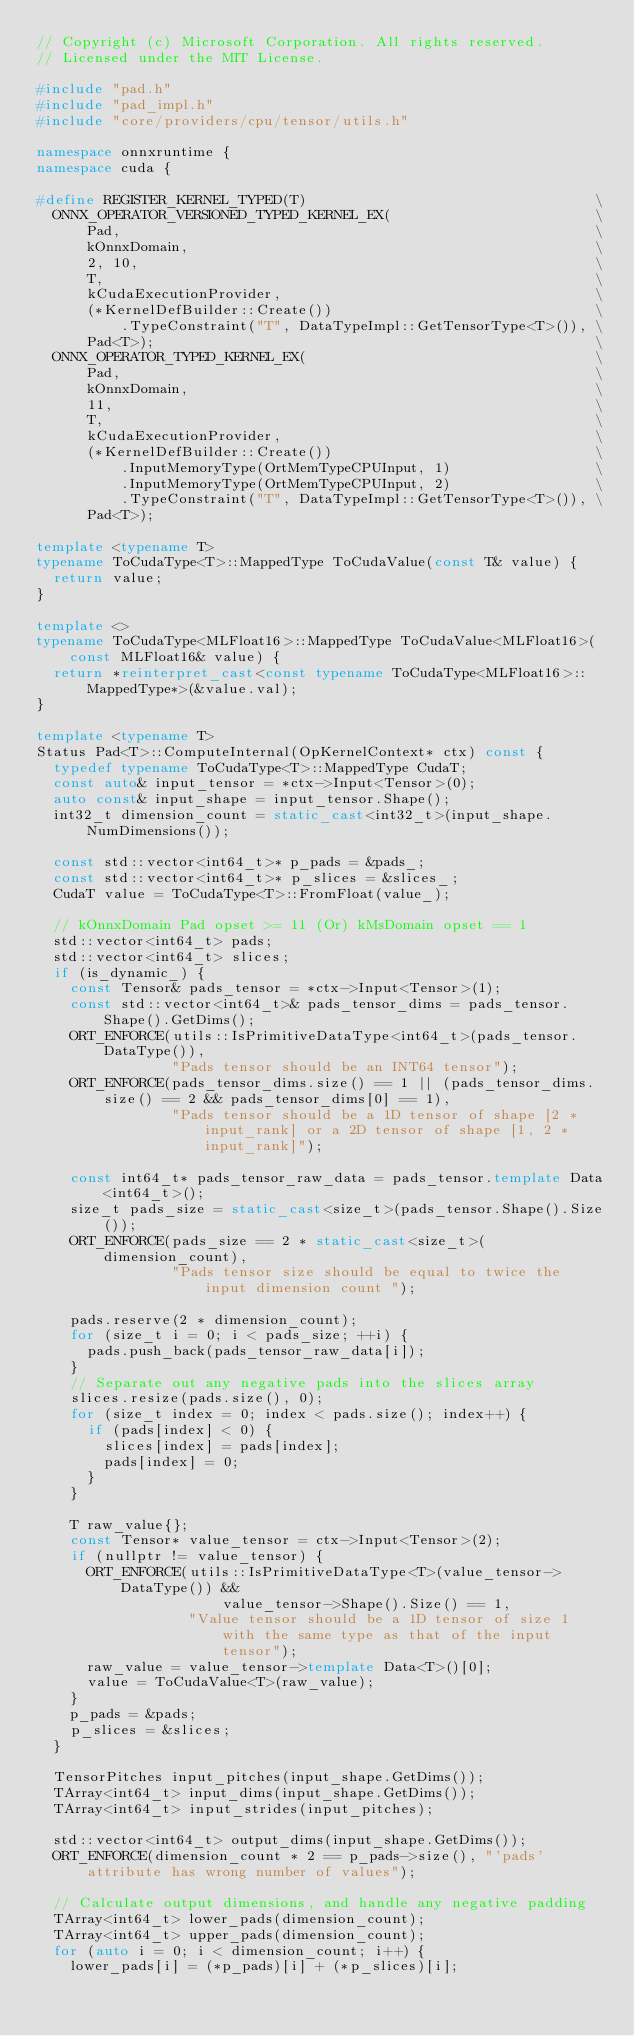Convert code to text. <code><loc_0><loc_0><loc_500><loc_500><_C++_>// Copyright (c) Microsoft Corporation. All rights reserved.
// Licensed under the MIT License.

#include "pad.h"
#include "pad_impl.h"
#include "core/providers/cpu/tensor/utils.h"

namespace onnxruntime {
namespace cuda {

#define REGISTER_KERNEL_TYPED(T)                                  \
  ONNX_OPERATOR_VERSIONED_TYPED_KERNEL_EX(                        \
      Pad,                                                        \
      kOnnxDomain,                                                \
      2, 10,                                                      \
      T,                                                          \
      kCudaExecutionProvider,                                     \
      (*KernelDefBuilder::Create())                               \
          .TypeConstraint("T", DataTypeImpl::GetTensorType<T>()), \
      Pad<T>);                                                    \
  ONNX_OPERATOR_TYPED_KERNEL_EX(                                  \
      Pad,                                                        \
      kOnnxDomain,                                                \
      11,                                                         \
      T,                                                          \
      kCudaExecutionProvider,                                     \
      (*KernelDefBuilder::Create())                               \
          .InputMemoryType(OrtMemTypeCPUInput, 1)                 \
          .InputMemoryType(OrtMemTypeCPUInput, 2)                 \
          .TypeConstraint("T", DataTypeImpl::GetTensorType<T>()), \
      Pad<T>);

template <typename T>
typename ToCudaType<T>::MappedType ToCudaValue(const T& value) {
  return value;
}

template <>
typename ToCudaType<MLFloat16>::MappedType ToCudaValue<MLFloat16>(const MLFloat16& value) {
  return *reinterpret_cast<const typename ToCudaType<MLFloat16>::MappedType*>(&value.val);
}

template <typename T>
Status Pad<T>::ComputeInternal(OpKernelContext* ctx) const {
  typedef typename ToCudaType<T>::MappedType CudaT;
  const auto& input_tensor = *ctx->Input<Tensor>(0);
  auto const& input_shape = input_tensor.Shape();
  int32_t dimension_count = static_cast<int32_t>(input_shape.NumDimensions());

  const std::vector<int64_t>* p_pads = &pads_;
  const std::vector<int64_t>* p_slices = &slices_;
  CudaT value = ToCudaType<T>::FromFloat(value_);

  // kOnnxDomain Pad opset >= 11 (Or) kMsDomain opset == 1
  std::vector<int64_t> pads;
  std::vector<int64_t> slices;
  if (is_dynamic_) {
    const Tensor& pads_tensor = *ctx->Input<Tensor>(1);
    const std::vector<int64_t>& pads_tensor_dims = pads_tensor.Shape().GetDims();
    ORT_ENFORCE(utils::IsPrimitiveDataType<int64_t>(pads_tensor.DataType()),
                "Pads tensor should be an INT64 tensor");
    ORT_ENFORCE(pads_tensor_dims.size() == 1 || (pads_tensor_dims.size() == 2 && pads_tensor_dims[0] == 1),
                "Pads tensor should be a 1D tensor of shape [2 * input_rank] or a 2D tensor of shape [1, 2 * input_rank]");

    const int64_t* pads_tensor_raw_data = pads_tensor.template Data<int64_t>();
    size_t pads_size = static_cast<size_t>(pads_tensor.Shape().Size());
    ORT_ENFORCE(pads_size == 2 * static_cast<size_t>(dimension_count),
                "Pads tensor size should be equal to twice the input dimension count ");

    pads.reserve(2 * dimension_count);
    for (size_t i = 0; i < pads_size; ++i) {
      pads.push_back(pads_tensor_raw_data[i]);
    }
    // Separate out any negative pads into the slices array
    slices.resize(pads.size(), 0);
    for (size_t index = 0; index < pads.size(); index++) {
      if (pads[index] < 0) {
        slices[index] = pads[index];
        pads[index] = 0;
      }
    }

    T raw_value{};
    const Tensor* value_tensor = ctx->Input<Tensor>(2);
    if (nullptr != value_tensor) {
      ORT_ENFORCE(utils::IsPrimitiveDataType<T>(value_tensor->DataType()) &&
                      value_tensor->Shape().Size() == 1,
                  "Value tensor should be a 1D tensor of size 1 with the same type as that of the input tensor");
      raw_value = value_tensor->template Data<T>()[0];
      value = ToCudaValue<T>(raw_value);
    }
    p_pads = &pads;
    p_slices = &slices;
  }

  TensorPitches input_pitches(input_shape.GetDims());
  TArray<int64_t> input_dims(input_shape.GetDims());
  TArray<int64_t> input_strides(input_pitches);

  std::vector<int64_t> output_dims(input_shape.GetDims());
  ORT_ENFORCE(dimension_count * 2 == p_pads->size(), "'pads' attribute has wrong number of values");

  // Calculate output dimensions, and handle any negative padding
  TArray<int64_t> lower_pads(dimension_count);
  TArray<int64_t> upper_pads(dimension_count);
  for (auto i = 0; i < dimension_count; i++) {
    lower_pads[i] = (*p_pads)[i] + (*p_slices)[i];</code> 